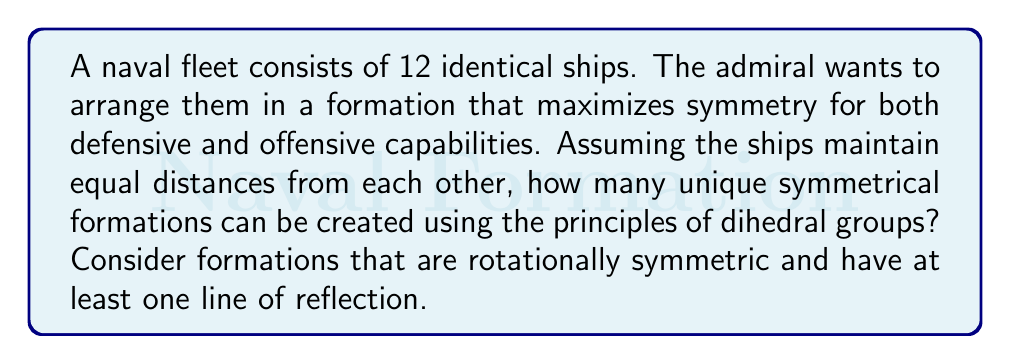Show me your answer to this math problem. To solve this problem, we need to consider the dihedral groups $D_n$ that can be formed with 12 ships. The dihedral group $D_n$ represents the symmetries of a regular n-gon, including rotations and reflections.

1) First, we need to find the factors of 12:
   $12 = 1 \times 12 = 2 \times 6 = 3 \times 4$

2) This means we can form regular polygons with 1, 2, 3, 4, 6, or 12 sides using all 12 ships.

3) Let's consider each case:

   a) $n = 1$: This would be a single point with all 12 ships stacked. This doesn't meet our criteria for a formation.
   
   b) $n = 2$: This would be a line formation with 6 ships on each side. This forms the dihedral group $D_2$.
   
   c) $n = 3$: An equilateral triangle with 4 ships on each side. This forms $D_3$.
   
   d) $n = 4$: A square with 3 ships on each side. This forms $D_4$.
   
   e) $n = 6$: A regular hexagon with 2 ships on each side. This forms $D_6$.
   
   f) $n = 12$: A regular dodecagon with 1 ship on each vertex. This forms $D_{12}$.

4) All of these formations (b through f) satisfy our criteria of being rotationally symmetric and having at least one line of reflection.

5) Therefore, we have 5 unique symmetrical formations that can be created using the principles of dihedral groups.

This solution utilizes group theory principles, specifically the properties of dihedral groups, to determine the optimal fleet formations that maximize symmetry. These formations would allow for equal distribution of firepower in all directions and maintain consistent distances between ships, which is crucial for both offensive and defensive strategies in naval warfare.
Answer: 5 unique symmetrical formations 